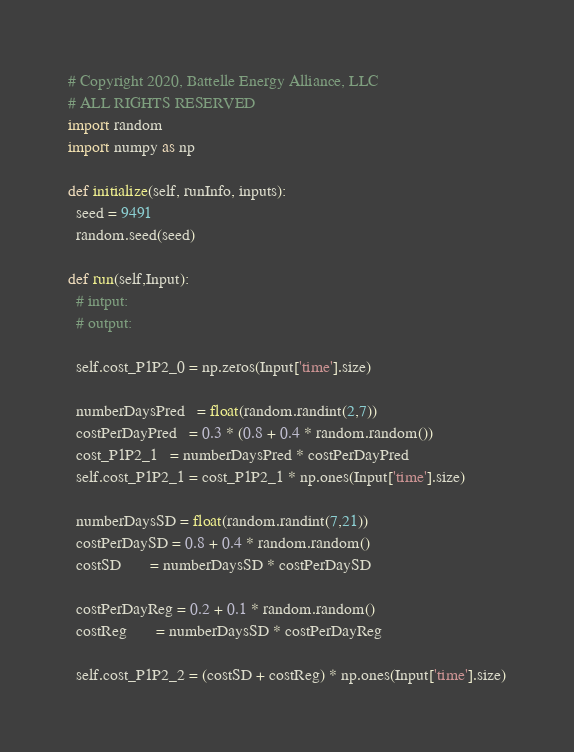<code> <loc_0><loc_0><loc_500><loc_500><_Python_># Copyright 2020, Battelle Energy Alliance, LLC
# ALL RIGHTS RESERVED
import random
import numpy as np

def initialize(self, runInfo, inputs):
  seed = 9491
  random.seed(seed)

def run(self,Input):
  # intput:
  # output:

  self.cost_P1P2_0 = np.zeros(Input['time'].size)

  numberDaysPred   = float(random.randint(2,7))
  costPerDayPred   = 0.3 * (0.8 + 0.4 * random.random())
  cost_P1P2_1   = numberDaysPred * costPerDayPred
  self.cost_P1P2_1 = cost_P1P2_1 * np.ones(Input['time'].size)

  numberDaysSD = float(random.randint(7,21))
  costPerDaySD = 0.8 + 0.4 * random.random()
  costSD       = numberDaysSD * costPerDaySD

  costPerDayReg = 0.2 + 0.1 * random.random()
  costReg       = numberDaysSD * costPerDayReg

  self.cost_P1P2_2 = (costSD + costReg) * np.ones(Input['time'].size)
</code> 